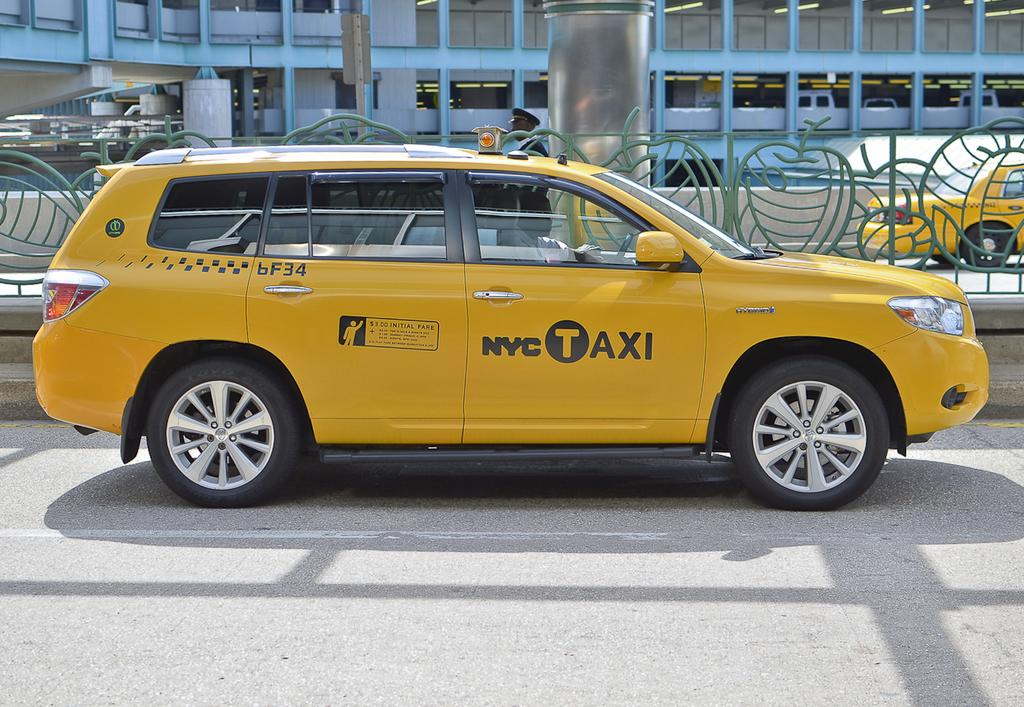<image>
Present a compact description of the photo's key features. Initial fare is $3 on this NYC Taxi. 